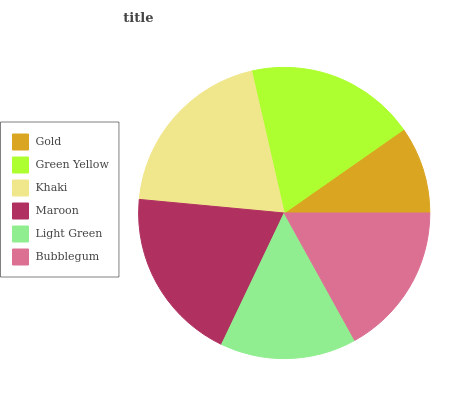Is Gold the minimum?
Answer yes or no. Yes. Is Khaki the maximum?
Answer yes or no. Yes. Is Green Yellow the minimum?
Answer yes or no. No. Is Green Yellow the maximum?
Answer yes or no. No. Is Green Yellow greater than Gold?
Answer yes or no. Yes. Is Gold less than Green Yellow?
Answer yes or no. Yes. Is Gold greater than Green Yellow?
Answer yes or no. No. Is Green Yellow less than Gold?
Answer yes or no. No. Is Green Yellow the high median?
Answer yes or no. Yes. Is Bubblegum the low median?
Answer yes or no. Yes. Is Khaki the high median?
Answer yes or no. No. Is Green Yellow the low median?
Answer yes or no. No. 